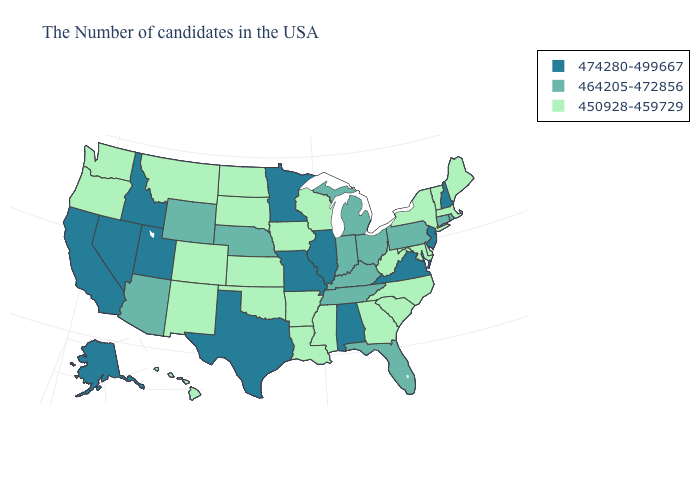What is the value of Kentucky?
Quick response, please. 464205-472856. What is the value of Alabama?
Give a very brief answer. 474280-499667. Name the states that have a value in the range 464205-472856?
Give a very brief answer. Rhode Island, Connecticut, Pennsylvania, Ohio, Florida, Michigan, Kentucky, Indiana, Tennessee, Nebraska, Wyoming, Arizona. Among the states that border California , which have the lowest value?
Write a very short answer. Oregon. What is the lowest value in states that border Nevada?
Be succinct. 450928-459729. Name the states that have a value in the range 474280-499667?
Give a very brief answer. New Hampshire, New Jersey, Virginia, Alabama, Illinois, Missouri, Minnesota, Texas, Utah, Idaho, Nevada, California, Alaska. Which states have the lowest value in the MidWest?
Quick response, please. Wisconsin, Iowa, Kansas, South Dakota, North Dakota. Does the map have missing data?
Keep it brief. No. What is the value of Alabama?
Quick response, please. 474280-499667. Does Connecticut have the highest value in the USA?
Be succinct. No. Does Nebraska have the highest value in the MidWest?
Give a very brief answer. No. What is the value of Wyoming?
Keep it brief. 464205-472856. Does the first symbol in the legend represent the smallest category?
Give a very brief answer. No. Is the legend a continuous bar?
Be succinct. No. Name the states that have a value in the range 450928-459729?
Be succinct. Maine, Massachusetts, Vermont, New York, Delaware, Maryland, North Carolina, South Carolina, West Virginia, Georgia, Wisconsin, Mississippi, Louisiana, Arkansas, Iowa, Kansas, Oklahoma, South Dakota, North Dakota, Colorado, New Mexico, Montana, Washington, Oregon, Hawaii. 